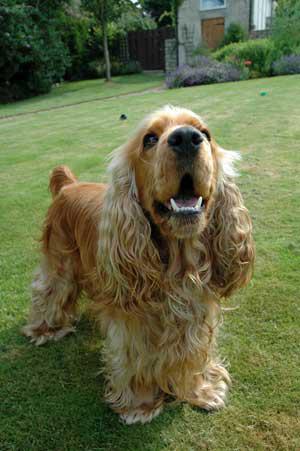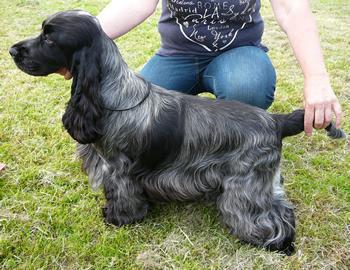The first image is the image on the left, the second image is the image on the right. Examine the images to the left and right. Is the description "There are two dogs with black fur and floppy ears." accurate? Answer yes or no. No. 